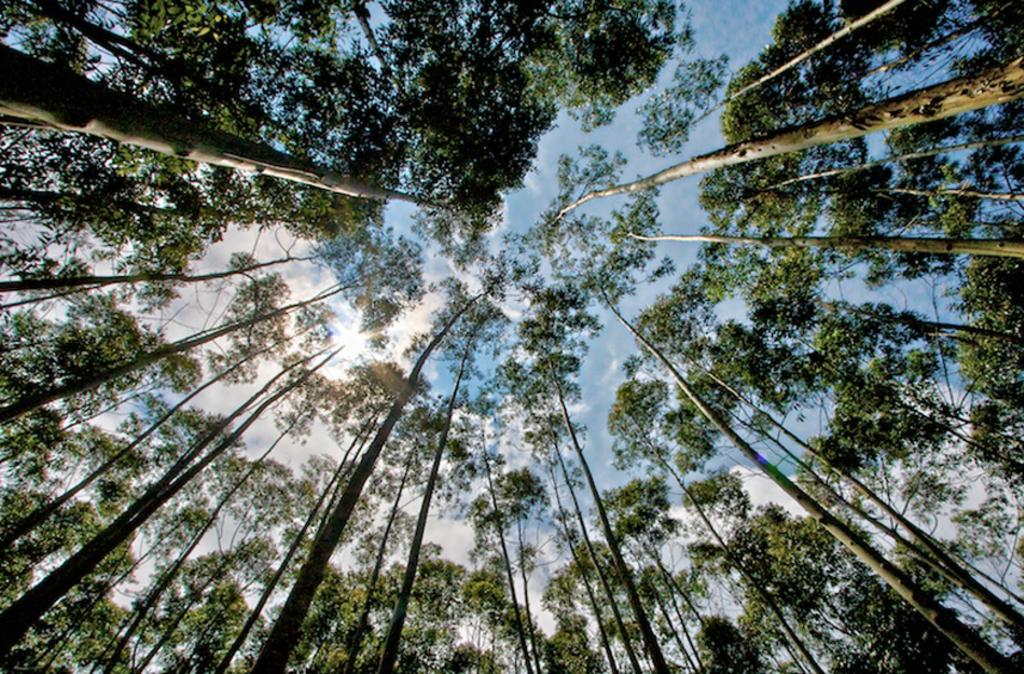What type of natural elements can be seen in the image? There are many trees in the image. What is the condition of the sky in the image? The sky is cloudy and pale blue. Can you tell me which actor is walking on the sidewalk in the image? There is no actor or sidewalk present in the image; it features trees and a cloudy, pale blue sky. 